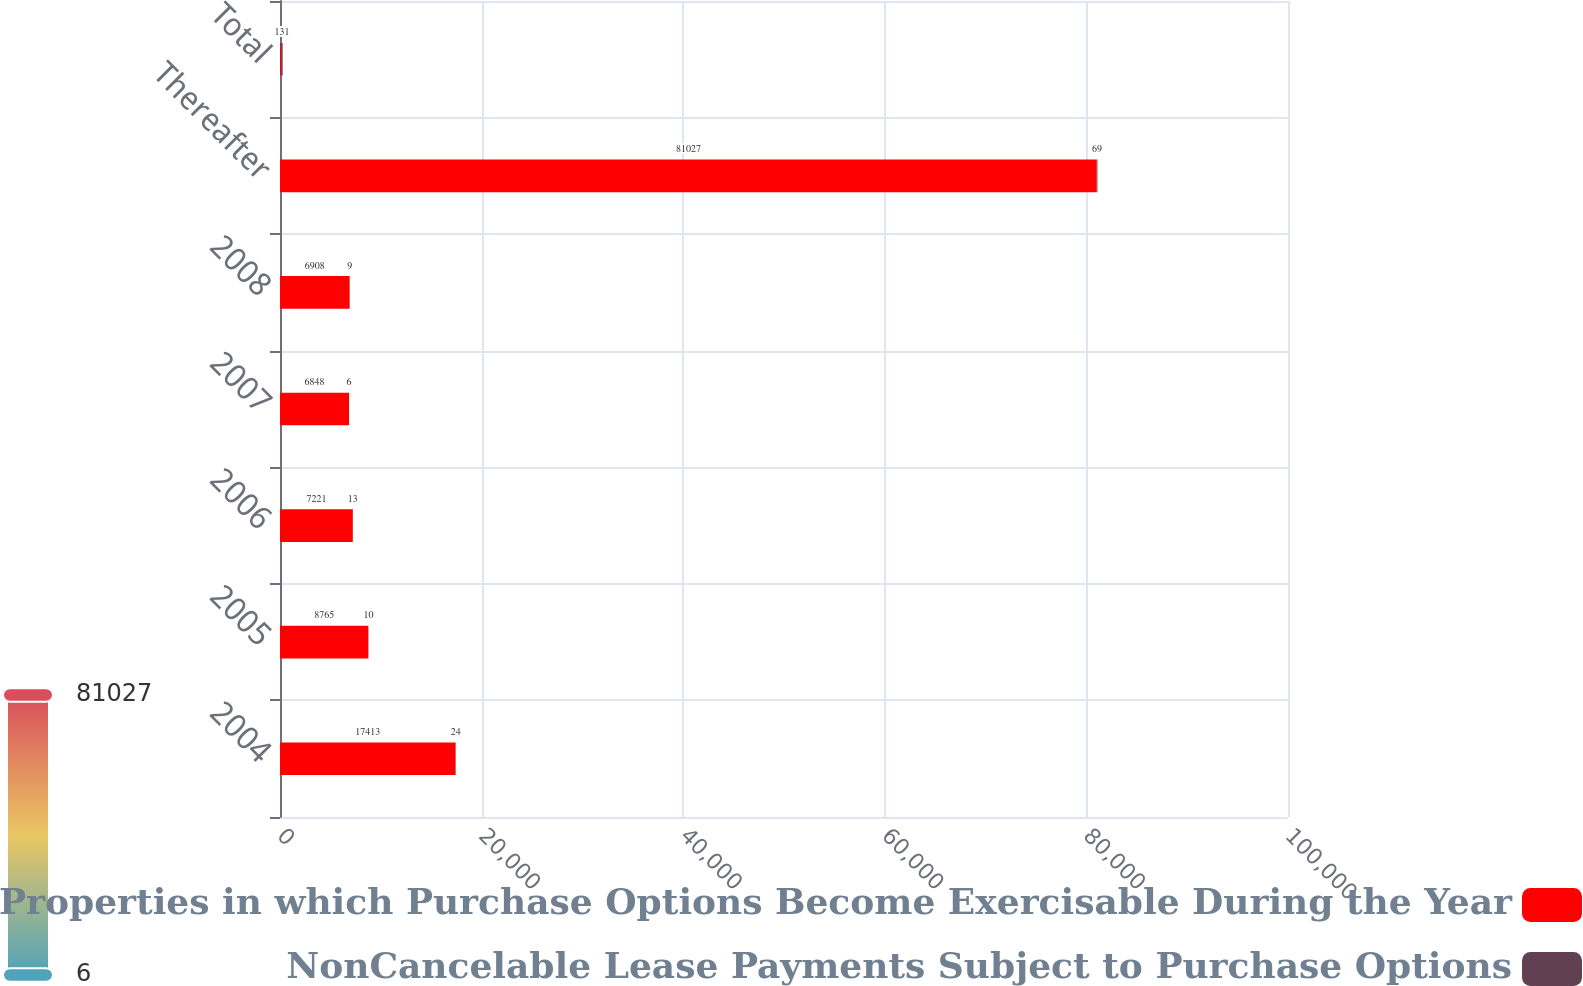Convert chart to OTSL. <chart><loc_0><loc_0><loc_500><loc_500><stacked_bar_chart><ecel><fcel>2004<fcel>2005<fcel>2006<fcel>2007<fcel>2008<fcel>Thereafter<fcel>Total<nl><fcel>Number of Properties in which Purchase Options Become Exercisable During the Year<fcel>17413<fcel>8765<fcel>7221<fcel>6848<fcel>6908<fcel>81027<fcel>131<nl><fcel>NonCancelable Lease Payments Subject to Purchase Options<fcel>24<fcel>10<fcel>13<fcel>6<fcel>9<fcel>69<fcel>131<nl></chart> 